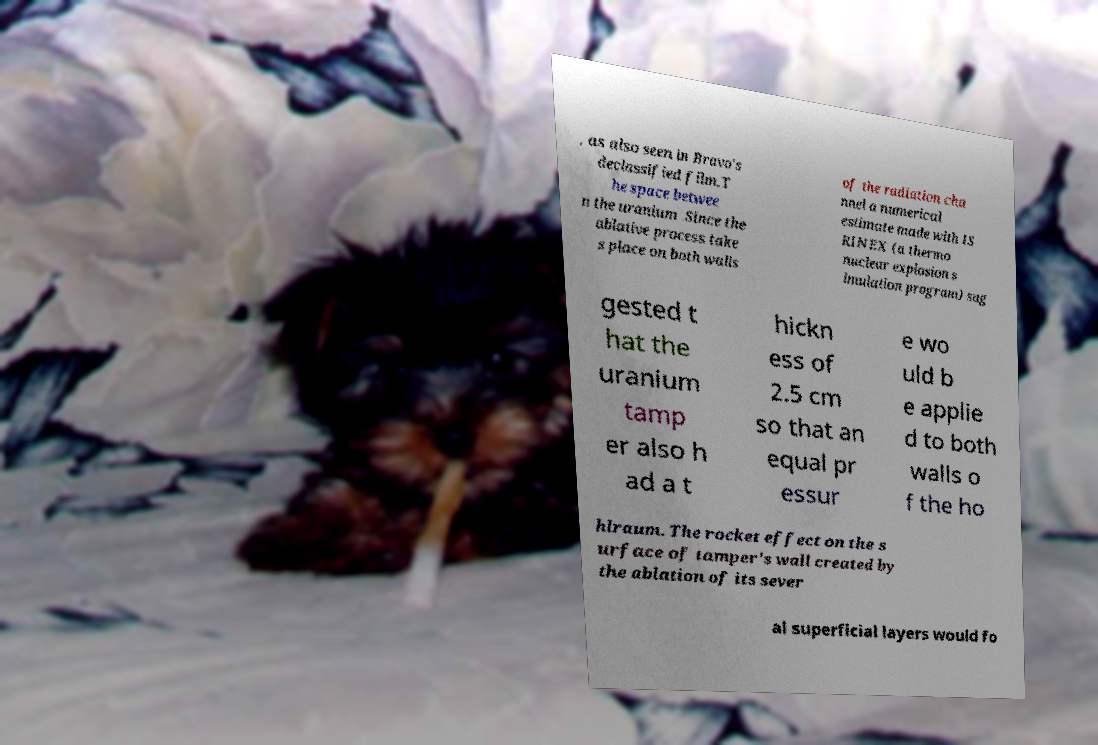For documentation purposes, I need the text within this image transcribed. Could you provide that? , as also seen in Bravo's declassified film.T he space betwee n the uranium .Since the ablative process take s place on both walls of the radiation cha nnel a numerical estimate made with IS RINEX (a thermo nuclear explosion s imulation program) sug gested t hat the uranium tamp er also h ad a t hickn ess of 2.5 cm so that an equal pr essur e wo uld b e applie d to both walls o f the ho hlraum. The rocket effect on the s urface of tamper's wall created by the ablation of its sever al superficial layers would fo 